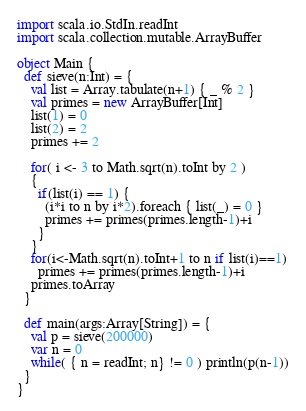Convert code to text. <code><loc_0><loc_0><loc_500><loc_500><_Scala_>import scala.io.StdIn.readInt
import scala.collection.mutable.ArrayBuffer

object Main {
  def sieve(n:Int) = {
    val list = Array.tabulate(n+1) { _ % 2 }
    val primes = new ArrayBuffer[Int]
    list(1) = 0
    list(2) = 2
    primes += 2

    for( i <- 3 to Math.sqrt(n).toInt by 2 )
    {
      if(list(i) == 1) {
        (i*i to n by i*2).foreach { list(_) = 0 }
        primes += primes(primes.length-1)+i
      }
    }
    for(i<-Math.sqrt(n).toInt+1 to n if list(i)==1)
      primes += primes(primes.length-1)+i
    primes.toArray
  }

  def main(args:Array[String]) = {
    val p = sieve(200000)
    var n = 0
    while( { n = readInt; n} != 0 ) println(p(n-1))
  }
}</code> 